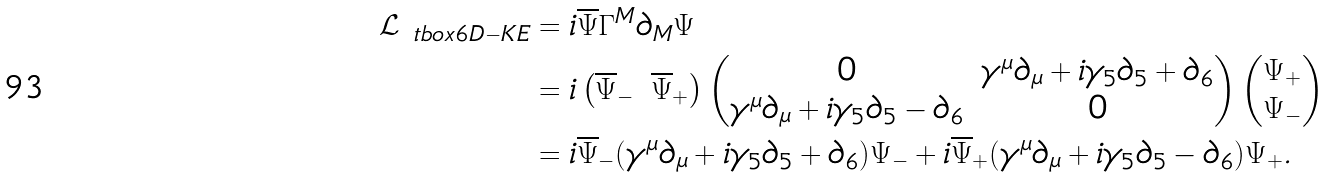<formula> <loc_0><loc_0><loc_500><loc_500>\mathcal { L } _ { \ t b o x { 6 D - K E } } & = i \overline { \Psi } \Gamma ^ { M } \partial _ { M } \Psi \\ & = i \begin{pmatrix} \overline { \Psi } _ { - } & \overline { \Psi } _ { + } \end{pmatrix} \begin{pmatrix} 0 & \gamma ^ { \mu } \partial _ { \mu } + i \gamma _ { 5 } \partial _ { 5 } + \partial _ { 6 } \\ \gamma ^ { \mu } \partial _ { \mu } + i \gamma _ { 5 } \partial _ { 5 } - \partial _ { 6 } & 0 \end{pmatrix} \begin{pmatrix} \Psi _ { + } \\ \Psi _ { - } \end{pmatrix} \\ & = i \overline { \Psi } _ { - } ( \gamma ^ { \mu } \partial _ { \mu } + i \gamma _ { 5 } \partial _ { 5 } + \partial _ { 6 } ) \Psi _ { - } + i \overline { \Psi } _ { + } ( \gamma ^ { \mu } \partial _ { \mu } + i \gamma _ { 5 } \partial _ { 5 } - \partial _ { 6 } ) \Psi _ { + } .</formula> 